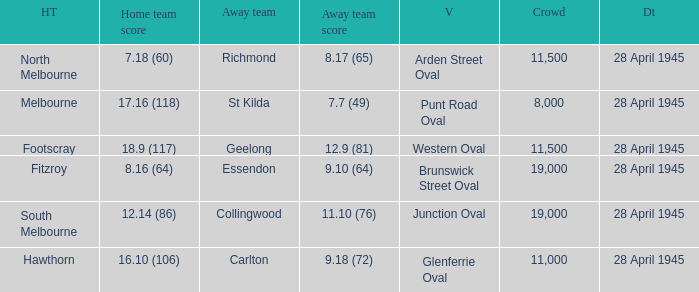What home team has an Away team of richmond? North Melbourne. 